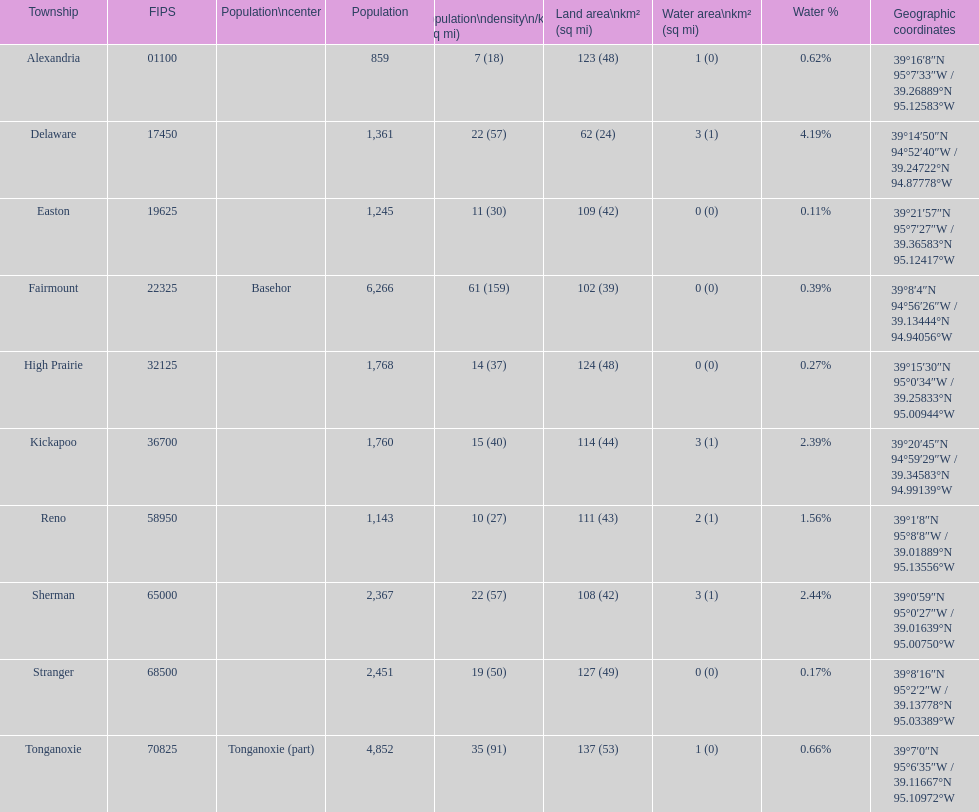Can you provide the count of townships within leavenworth county? 10. 